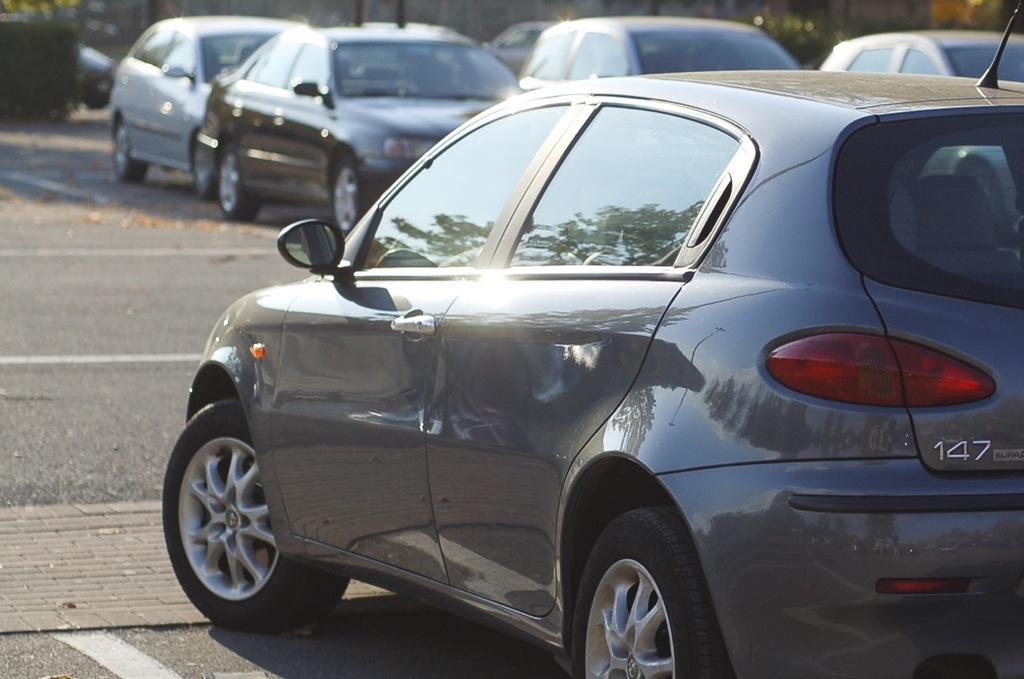What type of vehicles can be seen on the road in the image? There are cars on the road in the image. What can be seen in the background of the image? There are plants visible in the background of the image. What type of crack can be seen on the road in the image? There is no crack visible on the road in the image. What type of vest is being worn by the plants in the image? The plants in the image are not wearing any vests. 